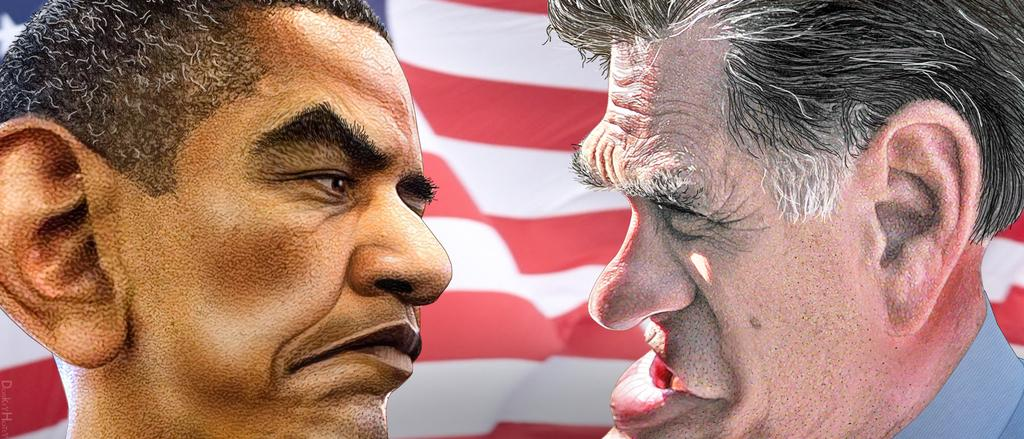How many people are present in the image? There are two people in the image. What can be seen on the faces of the people? The faces of the people are visible in the image. What is located in the background of the image? There is a flag in the background of the image. What type of butter is being sold at the store in the image? There is no store or butter present in the image. What kind of jewel is the person wearing in the image? There is no jewel visible on the people in the image. 